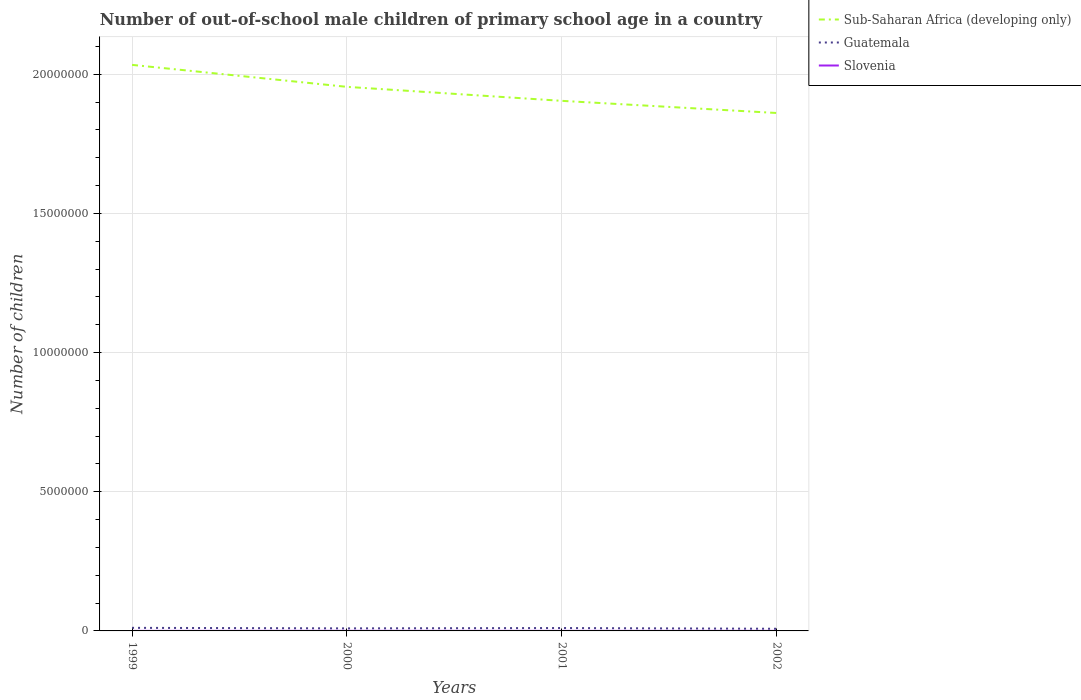How many different coloured lines are there?
Offer a very short reply. 3. Across all years, what is the maximum number of out-of-school male children in Sub-Saharan Africa (developing only)?
Provide a succinct answer. 1.86e+07. In which year was the number of out-of-school male children in Sub-Saharan Africa (developing only) maximum?
Your answer should be compact. 2002. What is the total number of out-of-school male children in Sub-Saharan Africa (developing only) in the graph?
Your answer should be very brief. 4.37e+05. What is the difference between the highest and the second highest number of out-of-school male children in Sub-Saharan Africa (developing only)?
Offer a terse response. 1.73e+06. What is the difference between the highest and the lowest number of out-of-school male children in Slovenia?
Provide a succinct answer. 1. Is the number of out-of-school male children in Slovenia strictly greater than the number of out-of-school male children in Sub-Saharan Africa (developing only) over the years?
Offer a very short reply. Yes. How many lines are there?
Offer a very short reply. 3. How many years are there in the graph?
Offer a very short reply. 4. What is the difference between two consecutive major ticks on the Y-axis?
Ensure brevity in your answer.  5.00e+06. Where does the legend appear in the graph?
Provide a succinct answer. Top right. How many legend labels are there?
Your answer should be very brief. 3. How are the legend labels stacked?
Your answer should be compact. Vertical. What is the title of the graph?
Ensure brevity in your answer.  Number of out-of-school male children of primary school age in a country. Does "Seychelles" appear as one of the legend labels in the graph?
Your response must be concise. No. What is the label or title of the X-axis?
Your answer should be very brief. Years. What is the label or title of the Y-axis?
Keep it short and to the point. Number of children. What is the Number of children in Sub-Saharan Africa (developing only) in 1999?
Your answer should be very brief. 2.03e+07. What is the Number of children in Guatemala in 1999?
Provide a short and direct response. 1.11e+05. What is the Number of children in Slovenia in 1999?
Offer a very short reply. 1793. What is the Number of children of Sub-Saharan Africa (developing only) in 2000?
Ensure brevity in your answer.  1.95e+07. What is the Number of children in Guatemala in 2000?
Offer a very short reply. 9.18e+04. What is the Number of children in Slovenia in 2000?
Your answer should be very brief. 2737. What is the Number of children in Sub-Saharan Africa (developing only) in 2001?
Your response must be concise. 1.90e+07. What is the Number of children in Guatemala in 2001?
Offer a terse response. 1.04e+05. What is the Number of children in Slovenia in 2001?
Provide a short and direct response. 1863. What is the Number of children of Sub-Saharan Africa (developing only) in 2002?
Your response must be concise. 1.86e+07. What is the Number of children of Guatemala in 2002?
Your response must be concise. 7.76e+04. What is the Number of children in Slovenia in 2002?
Make the answer very short. 1701. Across all years, what is the maximum Number of children of Sub-Saharan Africa (developing only)?
Keep it short and to the point. 2.03e+07. Across all years, what is the maximum Number of children in Guatemala?
Your answer should be compact. 1.11e+05. Across all years, what is the maximum Number of children of Slovenia?
Offer a very short reply. 2737. Across all years, what is the minimum Number of children in Sub-Saharan Africa (developing only)?
Keep it short and to the point. 1.86e+07. Across all years, what is the minimum Number of children of Guatemala?
Offer a terse response. 7.76e+04. Across all years, what is the minimum Number of children of Slovenia?
Offer a terse response. 1701. What is the total Number of children of Sub-Saharan Africa (developing only) in the graph?
Ensure brevity in your answer.  7.75e+07. What is the total Number of children in Guatemala in the graph?
Keep it short and to the point. 3.84e+05. What is the total Number of children of Slovenia in the graph?
Your answer should be compact. 8094. What is the difference between the Number of children in Sub-Saharan Africa (developing only) in 1999 and that in 2000?
Your answer should be very brief. 7.89e+05. What is the difference between the Number of children in Guatemala in 1999 and that in 2000?
Provide a short and direct response. 1.88e+04. What is the difference between the Number of children in Slovenia in 1999 and that in 2000?
Provide a short and direct response. -944. What is the difference between the Number of children of Sub-Saharan Africa (developing only) in 1999 and that in 2001?
Offer a terse response. 1.29e+06. What is the difference between the Number of children of Guatemala in 1999 and that in 2001?
Keep it short and to the point. 7080. What is the difference between the Number of children of Slovenia in 1999 and that in 2001?
Provide a short and direct response. -70. What is the difference between the Number of children of Sub-Saharan Africa (developing only) in 1999 and that in 2002?
Give a very brief answer. 1.73e+06. What is the difference between the Number of children of Guatemala in 1999 and that in 2002?
Offer a terse response. 3.29e+04. What is the difference between the Number of children in Slovenia in 1999 and that in 2002?
Give a very brief answer. 92. What is the difference between the Number of children of Sub-Saharan Africa (developing only) in 2000 and that in 2001?
Make the answer very short. 5.03e+05. What is the difference between the Number of children in Guatemala in 2000 and that in 2001?
Ensure brevity in your answer.  -1.17e+04. What is the difference between the Number of children of Slovenia in 2000 and that in 2001?
Ensure brevity in your answer.  874. What is the difference between the Number of children in Sub-Saharan Africa (developing only) in 2000 and that in 2002?
Your answer should be very brief. 9.39e+05. What is the difference between the Number of children of Guatemala in 2000 and that in 2002?
Keep it short and to the point. 1.41e+04. What is the difference between the Number of children in Slovenia in 2000 and that in 2002?
Ensure brevity in your answer.  1036. What is the difference between the Number of children in Sub-Saharan Africa (developing only) in 2001 and that in 2002?
Keep it short and to the point. 4.37e+05. What is the difference between the Number of children of Guatemala in 2001 and that in 2002?
Provide a succinct answer. 2.59e+04. What is the difference between the Number of children of Slovenia in 2001 and that in 2002?
Offer a very short reply. 162. What is the difference between the Number of children of Sub-Saharan Africa (developing only) in 1999 and the Number of children of Guatemala in 2000?
Offer a terse response. 2.02e+07. What is the difference between the Number of children in Sub-Saharan Africa (developing only) in 1999 and the Number of children in Slovenia in 2000?
Ensure brevity in your answer.  2.03e+07. What is the difference between the Number of children in Guatemala in 1999 and the Number of children in Slovenia in 2000?
Keep it short and to the point. 1.08e+05. What is the difference between the Number of children of Sub-Saharan Africa (developing only) in 1999 and the Number of children of Guatemala in 2001?
Offer a very short reply. 2.02e+07. What is the difference between the Number of children of Sub-Saharan Africa (developing only) in 1999 and the Number of children of Slovenia in 2001?
Keep it short and to the point. 2.03e+07. What is the difference between the Number of children of Guatemala in 1999 and the Number of children of Slovenia in 2001?
Your response must be concise. 1.09e+05. What is the difference between the Number of children of Sub-Saharan Africa (developing only) in 1999 and the Number of children of Guatemala in 2002?
Ensure brevity in your answer.  2.03e+07. What is the difference between the Number of children of Sub-Saharan Africa (developing only) in 1999 and the Number of children of Slovenia in 2002?
Offer a terse response. 2.03e+07. What is the difference between the Number of children in Guatemala in 1999 and the Number of children in Slovenia in 2002?
Provide a short and direct response. 1.09e+05. What is the difference between the Number of children of Sub-Saharan Africa (developing only) in 2000 and the Number of children of Guatemala in 2001?
Your answer should be compact. 1.94e+07. What is the difference between the Number of children in Sub-Saharan Africa (developing only) in 2000 and the Number of children in Slovenia in 2001?
Ensure brevity in your answer.  1.95e+07. What is the difference between the Number of children in Guatemala in 2000 and the Number of children in Slovenia in 2001?
Make the answer very short. 8.99e+04. What is the difference between the Number of children in Sub-Saharan Africa (developing only) in 2000 and the Number of children in Guatemala in 2002?
Your answer should be compact. 1.95e+07. What is the difference between the Number of children of Sub-Saharan Africa (developing only) in 2000 and the Number of children of Slovenia in 2002?
Your answer should be compact. 1.95e+07. What is the difference between the Number of children in Guatemala in 2000 and the Number of children in Slovenia in 2002?
Provide a succinct answer. 9.01e+04. What is the difference between the Number of children of Sub-Saharan Africa (developing only) in 2001 and the Number of children of Guatemala in 2002?
Your response must be concise. 1.90e+07. What is the difference between the Number of children in Sub-Saharan Africa (developing only) in 2001 and the Number of children in Slovenia in 2002?
Provide a short and direct response. 1.90e+07. What is the difference between the Number of children of Guatemala in 2001 and the Number of children of Slovenia in 2002?
Make the answer very short. 1.02e+05. What is the average Number of children in Sub-Saharan Africa (developing only) per year?
Provide a short and direct response. 1.94e+07. What is the average Number of children of Guatemala per year?
Offer a very short reply. 9.59e+04. What is the average Number of children in Slovenia per year?
Your answer should be very brief. 2023.5. In the year 1999, what is the difference between the Number of children in Sub-Saharan Africa (developing only) and Number of children in Guatemala?
Ensure brevity in your answer.  2.02e+07. In the year 1999, what is the difference between the Number of children of Sub-Saharan Africa (developing only) and Number of children of Slovenia?
Offer a very short reply. 2.03e+07. In the year 1999, what is the difference between the Number of children of Guatemala and Number of children of Slovenia?
Offer a very short reply. 1.09e+05. In the year 2000, what is the difference between the Number of children of Sub-Saharan Africa (developing only) and Number of children of Guatemala?
Your answer should be very brief. 1.95e+07. In the year 2000, what is the difference between the Number of children in Sub-Saharan Africa (developing only) and Number of children in Slovenia?
Your response must be concise. 1.95e+07. In the year 2000, what is the difference between the Number of children in Guatemala and Number of children in Slovenia?
Your answer should be compact. 8.91e+04. In the year 2001, what is the difference between the Number of children in Sub-Saharan Africa (developing only) and Number of children in Guatemala?
Your response must be concise. 1.89e+07. In the year 2001, what is the difference between the Number of children of Sub-Saharan Africa (developing only) and Number of children of Slovenia?
Ensure brevity in your answer.  1.90e+07. In the year 2001, what is the difference between the Number of children in Guatemala and Number of children in Slovenia?
Your answer should be very brief. 1.02e+05. In the year 2002, what is the difference between the Number of children in Sub-Saharan Africa (developing only) and Number of children in Guatemala?
Your answer should be compact. 1.85e+07. In the year 2002, what is the difference between the Number of children of Sub-Saharan Africa (developing only) and Number of children of Slovenia?
Make the answer very short. 1.86e+07. In the year 2002, what is the difference between the Number of children in Guatemala and Number of children in Slovenia?
Provide a short and direct response. 7.59e+04. What is the ratio of the Number of children of Sub-Saharan Africa (developing only) in 1999 to that in 2000?
Your answer should be compact. 1.04. What is the ratio of the Number of children of Guatemala in 1999 to that in 2000?
Offer a very short reply. 1.2. What is the ratio of the Number of children of Slovenia in 1999 to that in 2000?
Make the answer very short. 0.66. What is the ratio of the Number of children of Sub-Saharan Africa (developing only) in 1999 to that in 2001?
Your response must be concise. 1.07. What is the ratio of the Number of children of Guatemala in 1999 to that in 2001?
Offer a terse response. 1.07. What is the ratio of the Number of children in Slovenia in 1999 to that in 2001?
Offer a very short reply. 0.96. What is the ratio of the Number of children of Sub-Saharan Africa (developing only) in 1999 to that in 2002?
Make the answer very short. 1.09. What is the ratio of the Number of children in Guatemala in 1999 to that in 2002?
Keep it short and to the point. 1.42. What is the ratio of the Number of children in Slovenia in 1999 to that in 2002?
Your answer should be compact. 1.05. What is the ratio of the Number of children in Sub-Saharan Africa (developing only) in 2000 to that in 2001?
Provide a succinct answer. 1.03. What is the ratio of the Number of children in Guatemala in 2000 to that in 2001?
Give a very brief answer. 0.89. What is the ratio of the Number of children of Slovenia in 2000 to that in 2001?
Ensure brevity in your answer.  1.47. What is the ratio of the Number of children of Sub-Saharan Africa (developing only) in 2000 to that in 2002?
Give a very brief answer. 1.05. What is the ratio of the Number of children of Guatemala in 2000 to that in 2002?
Give a very brief answer. 1.18. What is the ratio of the Number of children of Slovenia in 2000 to that in 2002?
Your answer should be compact. 1.61. What is the ratio of the Number of children of Sub-Saharan Africa (developing only) in 2001 to that in 2002?
Your answer should be compact. 1.02. What is the ratio of the Number of children in Guatemala in 2001 to that in 2002?
Ensure brevity in your answer.  1.33. What is the ratio of the Number of children of Slovenia in 2001 to that in 2002?
Give a very brief answer. 1.1. What is the difference between the highest and the second highest Number of children in Sub-Saharan Africa (developing only)?
Your response must be concise. 7.89e+05. What is the difference between the highest and the second highest Number of children in Guatemala?
Give a very brief answer. 7080. What is the difference between the highest and the second highest Number of children in Slovenia?
Ensure brevity in your answer.  874. What is the difference between the highest and the lowest Number of children in Sub-Saharan Africa (developing only)?
Provide a succinct answer. 1.73e+06. What is the difference between the highest and the lowest Number of children in Guatemala?
Ensure brevity in your answer.  3.29e+04. What is the difference between the highest and the lowest Number of children of Slovenia?
Offer a very short reply. 1036. 